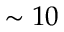<formula> <loc_0><loc_0><loc_500><loc_500>\sim 1 0</formula> 